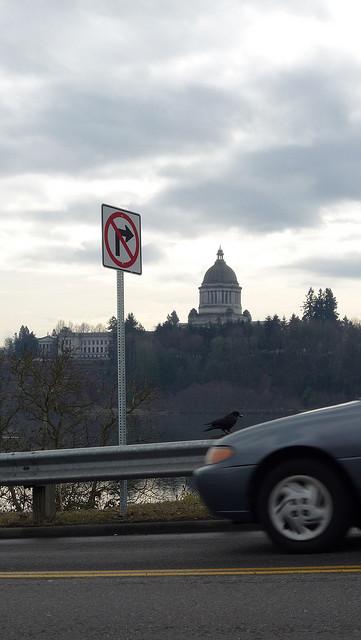Where is the arrow pointing?
Give a very brief answer. Right. Is it legal to turn right?
Short answer required. No. What kind of vehicle is shown?
Give a very brief answer. Car. 